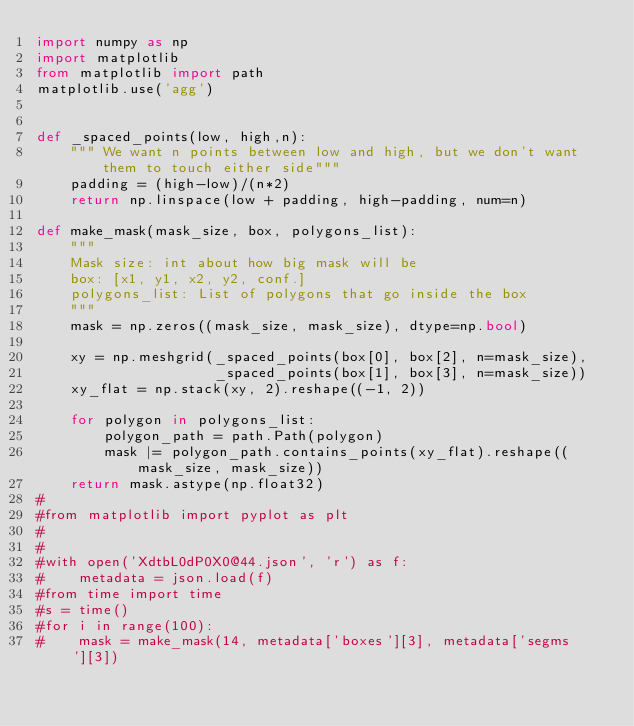<code> <loc_0><loc_0><loc_500><loc_500><_Python_>import numpy as np
import matplotlib
from matplotlib import path
matplotlib.use('agg')


def _spaced_points(low, high,n):
    """ We want n points between low and high, but we don't want them to touch either side"""
    padding = (high-low)/(n*2)
    return np.linspace(low + padding, high-padding, num=n)

def make_mask(mask_size, box, polygons_list):
    """
    Mask size: int about how big mask will be
    box: [x1, y1, x2, y2, conf.]
    polygons_list: List of polygons that go inside the box
    """
    mask = np.zeros((mask_size, mask_size), dtype=np.bool)
    
    xy = np.meshgrid(_spaced_points(box[0], box[2], n=mask_size),
                     _spaced_points(box[1], box[3], n=mask_size)) 
    xy_flat = np.stack(xy, 2).reshape((-1, 2))

    for polygon in polygons_list:
        polygon_path = path.Path(polygon)
        mask |= polygon_path.contains_points(xy_flat).reshape((mask_size, mask_size))
    return mask.astype(np.float32)
#
#from matplotlib import pyplot as plt
#
#
#with open('XdtbL0dP0X0@44.json', 'r') as f:
#    metadata = json.load(f)
#from time import time
#s = time()
#for i in range(100):
#    mask = make_mask(14, metadata['boxes'][3], metadata['segms'][3])</code> 